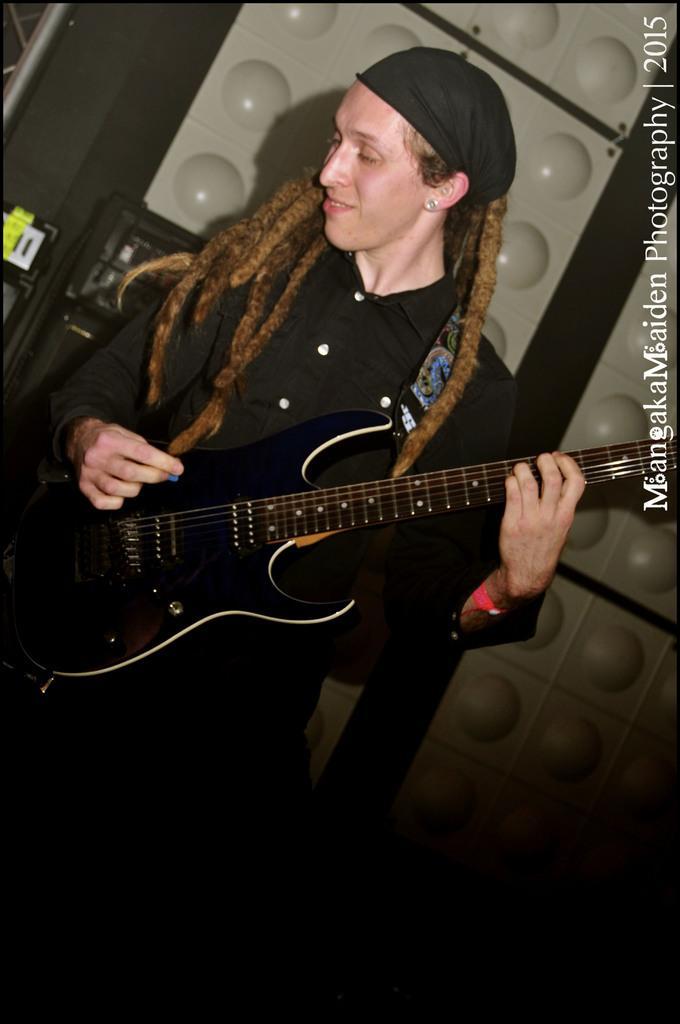Please provide a concise description of this image. In this image I can see a person wearing black color dress is holding a guitar in hands. In the background I can see few objects which are black and grey in color. 